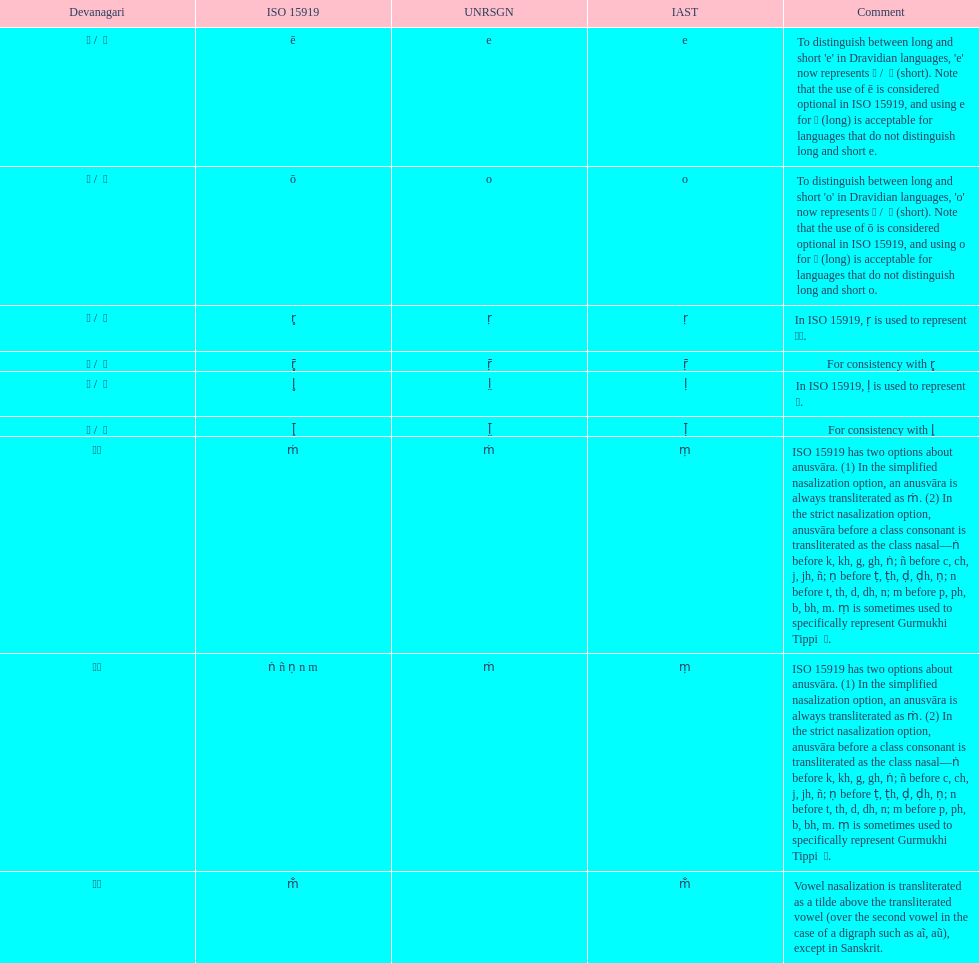This table shows the difference between how many transliterations? 3. 